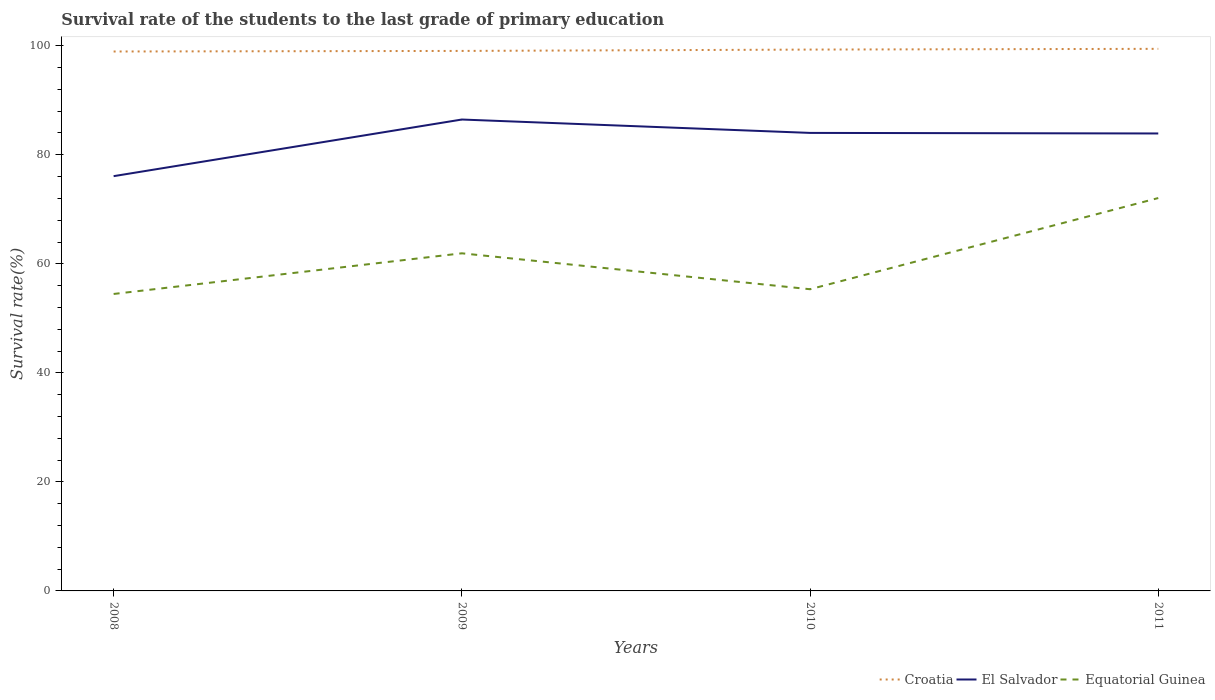How many different coloured lines are there?
Ensure brevity in your answer.  3. Is the number of lines equal to the number of legend labels?
Give a very brief answer. Yes. Across all years, what is the maximum survival rate of the students in Croatia?
Your answer should be very brief. 98.95. What is the total survival rate of the students in El Salvador in the graph?
Make the answer very short. -7.83. What is the difference between the highest and the second highest survival rate of the students in Croatia?
Offer a terse response. 0.49. What is the difference between two consecutive major ticks on the Y-axis?
Keep it short and to the point. 20. Does the graph contain any zero values?
Ensure brevity in your answer.  No. Does the graph contain grids?
Your response must be concise. No. How are the legend labels stacked?
Offer a terse response. Horizontal. What is the title of the graph?
Your answer should be compact. Survival rate of the students to the last grade of primary education. Does "Kenya" appear as one of the legend labels in the graph?
Provide a succinct answer. No. What is the label or title of the Y-axis?
Your answer should be very brief. Survival rate(%). What is the Survival rate(%) of Croatia in 2008?
Keep it short and to the point. 98.95. What is the Survival rate(%) of El Salvador in 2008?
Your response must be concise. 76.08. What is the Survival rate(%) of Equatorial Guinea in 2008?
Provide a short and direct response. 54.47. What is the Survival rate(%) of Croatia in 2009?
Offer a very short reply. 99.06. What is the Survival rate(%) in El Salvador in 2009?
Provide a succinct answer. 86.47. What is the Survival rate(%) in Equatorial Guinea in 2009?
Ensure brevity in your answer.  61.93. What is the Survival rate(%) of Croatia in 2010?
Your response must be concise. 99.3. What is the Survival rate(%) in El Salvador in 2010?
Ensure brevity in your answer.  84.02. What is the Survival rate(%) of Equatorial Guinea in 2010?
Ensure brevity in your answer.  55.34. What is the Survival rate(%) in Croatia in 2011?
Provide a short and direct response. 99.44. What is the Survival rate(%) of El Salvador in 2011?
Offer a very short reply. 83.91. What is the Survival rate(%) of Equatorial Guinea in 2011?
Your answer should be very brief. 72.07. Across all years, what is the maximum Survival rate(%) of Croatia?
Give a very brief answer. 99.44. Across all years, what is the maximum Survival rate(%) in El Salvador?
Your answer should be compact. 86.47. Across all years, what is the maximum Survival rate(%) in Equatorial Guinea?
Give a very brief answer. 72.07. Across all years, what is the minimum Survival rate(%) in Croatia?
Provide a succinct answer. 98.95. Across all years, what is the minimum Survival rate(%) in El Salvador?
Make the answer very short. 76.08. Across all years, what is the minimum Survival rate(%) of Equatorial Guinea?
Offer a terse response. 54.47. What is the total Survival rate(%) in Croatia in the graph?
Provide a succinct answer. 396.75. What is the total Survival rate(%) of El Salvador in the graph?
Ensure brevity in your answer.  330.49. What is the total Survival rate(%) in Equatorial Guinea in the graph?
Keep it short and to the point. 243.81. What is the difference between the Survival rate(%) in Croatia in 2008 and that in 2009?
Your response must be concise. -0.11. What is the difference between the Survival rate(%) in El Salvador in 2008 and that in 2009?
Keep it short and to the point. -10.39. What is the difference between the Survival rate(%) of Equatorial Guinea in 2008 and that in 2009?
Provide a short and direct response. -7.46. What is the difference between the Survival rate(%) of Croatia in 2008 and that in 2010?
Your answer should be compact. -0.35. What is the difference between the Survival rate(%) in El Salvador in 2008 and that in 2010?
Your answer should be very brief. -7.93. What is the difference between the Survival rate(%) of Equatorial Guinea in 2008 and that in 2010?
Offer a very short reply. -0.87. What is the difference between the Survival rate(%) in Croatia in 2008 and that in 2011?
Keep it short and to the point. -0.49. What is the difference between the Survival rate(%) of El Salvador in 2008 and that in 2011?
Your answer should be very brief. -7.83. What is the difference between the Survival rate(%) of Equatorial Guinea in 2008 and that in 2011?
Give a very brief answer. -17.6. What is the difference between the Survival rate(%) in Croatia in 2009 and that in 2010?
Make the answer very short. -0.25. What is the difference between the Survival rate(%) of El Salvador in 2009 and that in 2010?
Your answer should be very brief. 2.45. What is the difference between the Survival rate(%) of Equatorial Guinea in 2009 and that in 2010?
Provide a succinct answer. 6.59. What is the difference between the Survival rate(%) of Croatia in 2009 and that in 2011?
Offer a very short reply. -0.38. What is the difference between the Survival rate(%) of El Salvador in 2009 and that in 2011?
Make the answer very short. 2.56. What is the difference between the Survival rate(%) of Equatorial Guinea in 2009 and that in 2011?
Offer a terse response. -10.14. What is the difference between the Survival rate(%) in Croatia in 2010 and that in 2011?
Provide a succinct answer. -0.14. What is the difference between the Survival rate(%) in El Salvador in 2010 and that in 2011?
Make the answer very short. 0.1. What is the difference between the Survival rate(%) of Equatorial Guinea in 2010 and that in 2011?
Your answer should be compact. -16.73. What is the difference between the Survival rate(%) in Croatia in 2008 and the Survival rate(%) in El Salvador in 2009?
Ensure brevity in your answer.  12.48. What is the difference between the Survival rate(%) in Croatia in 2008 and the Survival rate(%) in Equatorial Guinea in 2009?
Provide a short and direct response. 37.02. What is the difference between the Survival rate(%) in El Salvador in 2008 and the Survival rate(%) in Equatorial Guinea in 2009?
Offer a very short reply. 14.15. What is the difference between the Survival rate(%) in Croatia in 2008 and the Survival rate(%) in El Salvador in 2010?
Keep it short and to the point. 14.93. What is the difference between the Survival rate(%) in Croatia in 2008 and the Survival rate(%) in Equatorial Guinea in 2010?
Keep it short and to the point. 43.61. What is the difference between the Survival rate(%) in El Salvador in 2008 and the Survival rate(%) in Equatorial Guinea in 2010?
Your answer should be very brief. 20.74. What is the difference between the Survival rate(%) in Croatia in 2008 and the Survival rate(%) in El Salvador in 2011?
Provide a succinct answer. 15.04. What is the difference between the Survival rate(%) in Croatia in 2008 and the Survival rate(%) in Equatorial Guinea in 2011?
Offer a terse response. 26.88. What is the difference between the Survival rate(%) of El Salvador in 2008 and the Survival rate(%) of Equatorial Guinea in 2011?
Keep it short and to the point. 4.01. What is the difference between the Survival rate(%) of Croatia in 2009 and the Survival rate(%) of El Salvador in 2010?
Make the answer very short. 15.04. What is the difference between the Survival rate(%) of Croatia in 2009 and the Survival rate(%) of Equatorial Guinea in 2010?
Keep it short and to the point. 43.71. What is the difference between the Survival rate(%) in El Salvador in 2009 and the Survival rate(%) in Equatorial Guinea in 2010?
Offer a very short reply. 31.13. What is the difference between the Survival rate(%) of Croatia in 2009 and the Survival rate(%) of El Salvador in 2011?
Your response must be concise. 15.14. What is the difference between the Survival rate(%) in Croatia in 2009 and the Survival rate(%) in Equatorial Guinea in 2011?
Your answer should be very brief. 26.99. What is the difference between the Survival rate(%) in El Salvador in 2009 and the Survival rate(%) in Equatorial Guinea in 2011?
Your answer should be very brief. 14.4. What is the difference between the Survival rate(%) of Croatia in 2010 and the Survival rate(%) of El Salvador in 2011?
Your answer should be compact. 15.39. What is the difference between the Survival rate(%) in Croatia in 2010 and the Survival rate(%) in Equatorial Guinea in 2011?
Your answer should be very brief. 27.23. What is the difference between the Survival rate(%) in El Salvador in 2010 and the Survival rate(%) in Equatorial Guinea in 2011?
Your response must be concise. 11.95. What is the average Survival rate(%) of Croatia per year?
Keep it short and to the point. 99.19. What is the average Survival rate(%) in El Salvador per year?
Keep it short and to the point. 82.62. What is the average Survival rate(%) in Equatorial Guinea per year?
Offer a very short reply. 60.95. In the year 2008, what is the difference between the Survival rate(%) of Croatia and Survival rate(%) of El Salvador?
Provide a short and direct response. 22.87. In the year 2008, what is the difference between the Survival rate(%) in Croatia and Survival rate(%) in Equatorial Guinea?
Offer a very short reply. 44.48. In the year 2008, what is the difference between the Survival rate(%) of El Salvador and Survival rate(%) of Equatorial Guinea?
Provide a succinct answer. 21.61. In the year 2009, what is the difference between the Survival rate(%) of Croatia and Survival rate(%) of El Salvador?
Make the answer very short. 12.58. In the year 2009, what is the difference between the Survival rate(%) in Croatia and Survival rate(%) in Equatorial Guinea?
Ensure brevity in your answer.  37.12. In the year 2009, what is the difference between the Survival rate(%) of El Salvador and Survival rate(%) of Equatorial Guinea?
Provide a short and direct response. 24.54. In the year 2010, what is the difference between the Survival rate(%) of Croatia and Survival rate(%) of El Salvador?
Offer a terse response. 15.29. In the year 2010, what is the difference between the Survival rate(%) of Croatia and Survival rate(%) of Equatorial Guinea?
Your answer should be compact. 43.96. In the year 2010, what is the difference between the Survival rate(%) in El Salvador and Survival rate(%) in Equatorial Guinea?
Your answer should be compact. 28.68. In the year 2011, what is the difference between the Survival rate(%) of Croatia and Survival rate(%) of El Salvador?
Your response must be concise. 15.52. In the year 2011, what is the difference between the Survival rate(%) of Croatia and Survival rate(%) of Equatorial Guinea?
Give a very brief answer. 27.37. In the year 2011, what is the difference between the Survival rate(%) of El Salvador and Survival rate(%) of Equatorial Guinea?
Your answer should be compact. 11.85. What is the ratio of the Survival rate(%) in Croatia in 2008 to that in 2009?
Offer a terse response. 1. What is the ratio of the Survival rate(%) in El Salvador in 2008 to that in 2009?
Your response must be concise. 0.88. What is the ratio of the Survival rate(%) in Equatorial Guinea in 2008 to that in 2009?
Your answer should be compact. 0.88. What is the ratio of the Survival rate(%) of Croatia in 2008 to that in 2010?
Provide a short and direct response. 1. What is the ratio of the Survival rate(%) of El Salvador in 2008 to that in 2010?
Your answer should be compact. 0.91. What is the ratio of the Survival rate(%) of Equatorial Guinea in 2008 to that in 2010?
Offer a terse response. 0.98. What is the ratio of the Survival rate(%) of Croatia in 2008 to that in 2011?
Make the answer very short. 1. What is the ratio of the Survival rate(%) in El Salvador in 2008 to that in 2011?
Your answer should be compact. 0.91. What is the ratio of the Survival rate(%) of Equatorial Guinea in 2008 to that in 2011?
Make the answer very short. 0.76. What is the ratio of the Survival rate(%) in Croatia in 2009 to that in 2010?
Offer a terse response. 1. What is the ratio of the Survival rate(%) in El Salvador in 2009 to that in 2010?
Provide a short and direct response. 1.03. What is the ratio of the Survival rate(%) in Equatorial Guinea in 2009 to that in 2010?
Ensure brevity in your answer.  1.12. What is the ratio of the Survival rate(%) of El Salvador in 2009 to that in 2011?
Ensure brevity in your answer.  1.03. What is the ratio of the Survival rate(%) in Equatorial Guinea in 2009 to that in 2011?
Your response must be concise. 0.86. What is the ratio of the Survival rate(%) of Croatia in 2010 to that in 2011?
Offer a terse response. 1. What is the ratio of the Survival rate(%) of El Salvador in 2010 to that in 2011?
Offer a terse response. 1. What is the ratio of the Survival rate(%) in Equatorial Guinea in 2010 to that in 2011?
Offer a terse response. 0.77. What is the difference between the highest and the second highest Survival rate(%) in Croatia?
Keep it short and to the point. 0.14. What is the difference between the highest and the second highest Survival rate(%) in El Salvador?
Offer a terse response. 2.45. What is the difference between the highest and the second highest Survival rate(%) of Equatorial Guinea?
Offer a very short reply. 10.14. What is the difference between the highest and the lowest Survival rate(%) of Croatia?
Provide a succinct answer. 0.49. What is the difference between the highest and the lowest Survival rate(%) in El Salvador?
Your response must be concise. 10.39. What is the difference between the highest and the lowest Survival rate(%) of Equatorial Guinea?
Your answer should be compact. 17.6. 